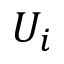<formula> <loc_0><loc_0><loc_500><loc_500>U _ { i }</formula> 